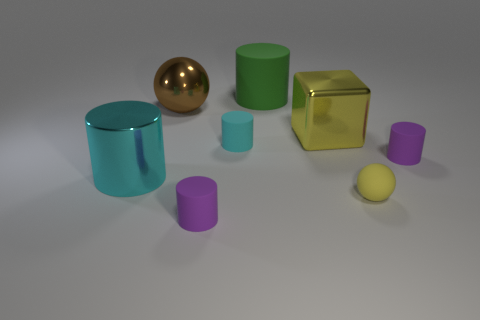Is the color of the metal block the same as the rubber sphere?
Provide a short and direct response. Yes. There is a green thing that is the same size as the cyan shiny cylinder; what material is it?
Provide a succinct answer. Rubber. How many big things are gray blocks or purple rubber things?
Offer a terse response. 0. Does the big cyan object have the same shape as the big green thing?
Offer a very short reply. Yes. What number of big objects are right of the big brown shiny sphere and behind the yellow metal object?
Your response must be concise. 1. Is there any other thing that has the same color as the tiny rubber ball?
Keep it short and to the point. Yes. What shape is the large green thing that is the same material as the tiny cyan thing?
Keep it short and to the point. Cylinder. Is the cyan matte cylinder the same size as the yellow rubber ball?
Give a very brief answer. Yes. Is the sphere that is behind the large cyan shiny cylinder made of the same material as the large green cylinder?
Provide a succinct answer. No. There is a purple matte thing on the left side of the big cylinder that is on the right side of the large brown metallic ball; what number of cyan rubber things are in front of it?
Provide a succinct answer. 0. 